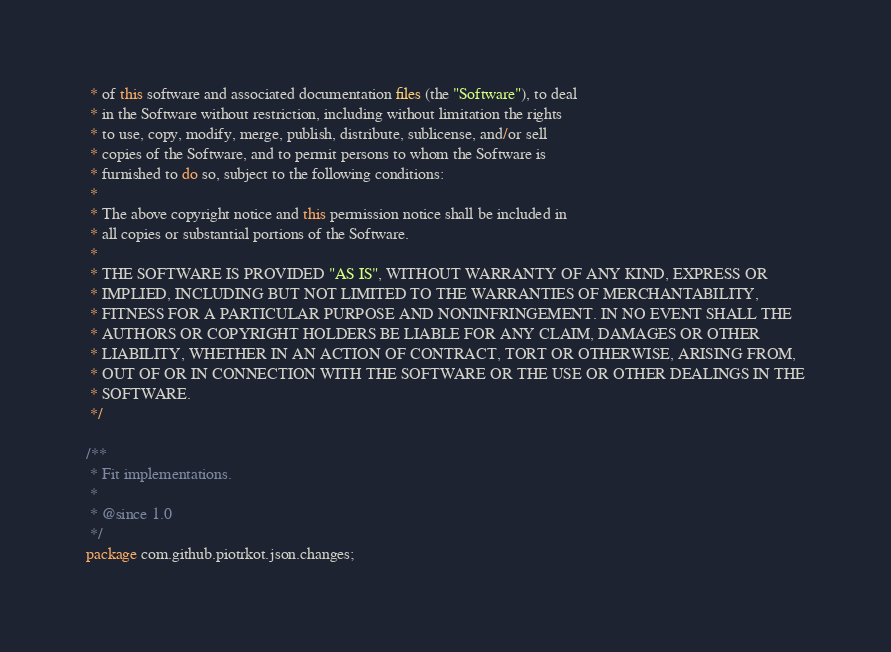Convert code to text. <code><loc_0><loc_0><loc_500><loc_500><_Java_> * of this software and associated documentation files (the "Software"), to deal
 * in the Software without restriction, including without limitation the rights
 * to use, copy, modify, merge, publish, distribute, sublicense, and/or sell
 * copies of the Software, and to permit persons to whom the Software is
 * furnished to do so, subject to the following conditions:
 *
 * The above copyright notice and this permission notice shall be included in
 * all copies or substantial portions of the Software.
 *
 * THE SOFTWARE IS PROVIDED "AS IS", WITHOUT WARRANTY OF ANY KIND, EXPRESS OR
 * IMPLIED, INCLUDING BUT NOT LIMITED TO THE WARRANTIES OF MERCHANTABILITY,
 * FITNESS FOR A PARTICULAR PURPOSE AND NONINFRINGEMENT. IN NO EVENT SHALL THE
 * AUTHORS OR COPYRIGHT HOLDERS BE LIABLE FOR ANY CLAIM, DAMAGES OR OTHER
 * LIABILITY, WHETHER IN AN ACTION OF CONTRACT, TORT OR OTHERWISE, ARISING FROM,
 * OUT OF OR IN CONNECTION WITH THE SOFTWARE OR THE USE OR OTHER DEALINGS IN THE
 * SOFTWARE.
 */

/**
 * Fit implementations.
 *
 * @since 1.0
 */
package com.github.piotrkot.json.changes;
</code> 